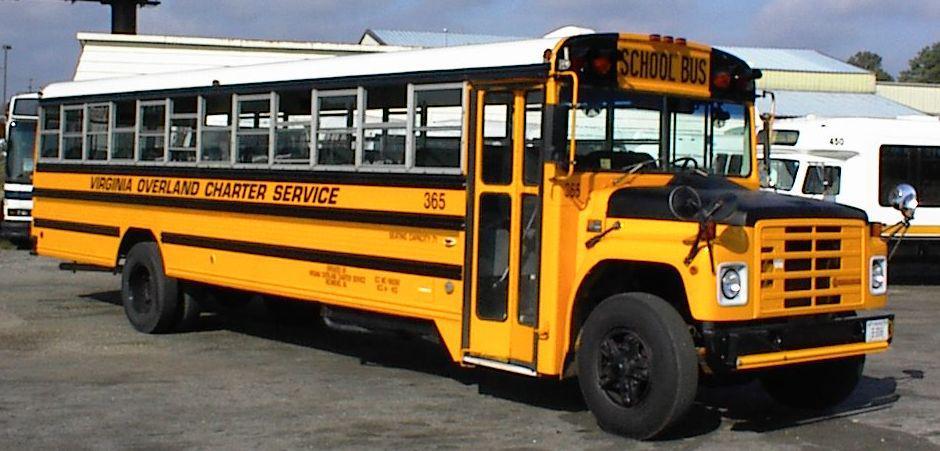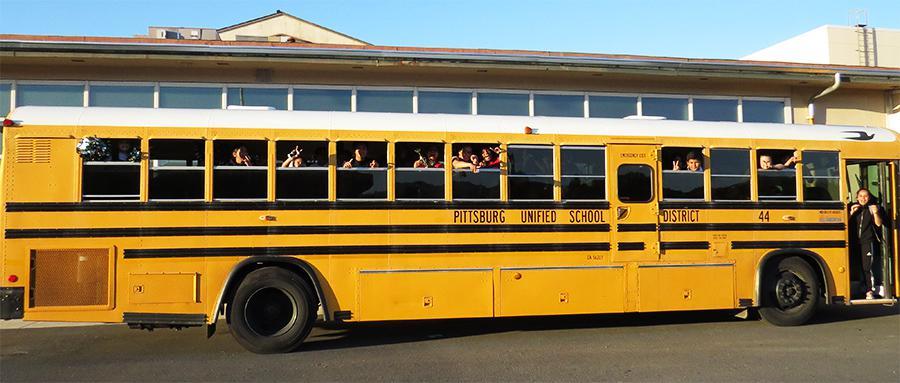The first image is the image on the left, the second image is the image on the right. Assess this claim about the two images: "One bus' passenger door is open.". Correct or not? Answer yes or no. Yes. The first image is the image on the left, the second image is the image on the right. For the images displayed, is the sentence "One image shows a horizontal view of a long bus with an extra door on the side near the middle of the bus." factually correct? Answer yes or no. Yes. 